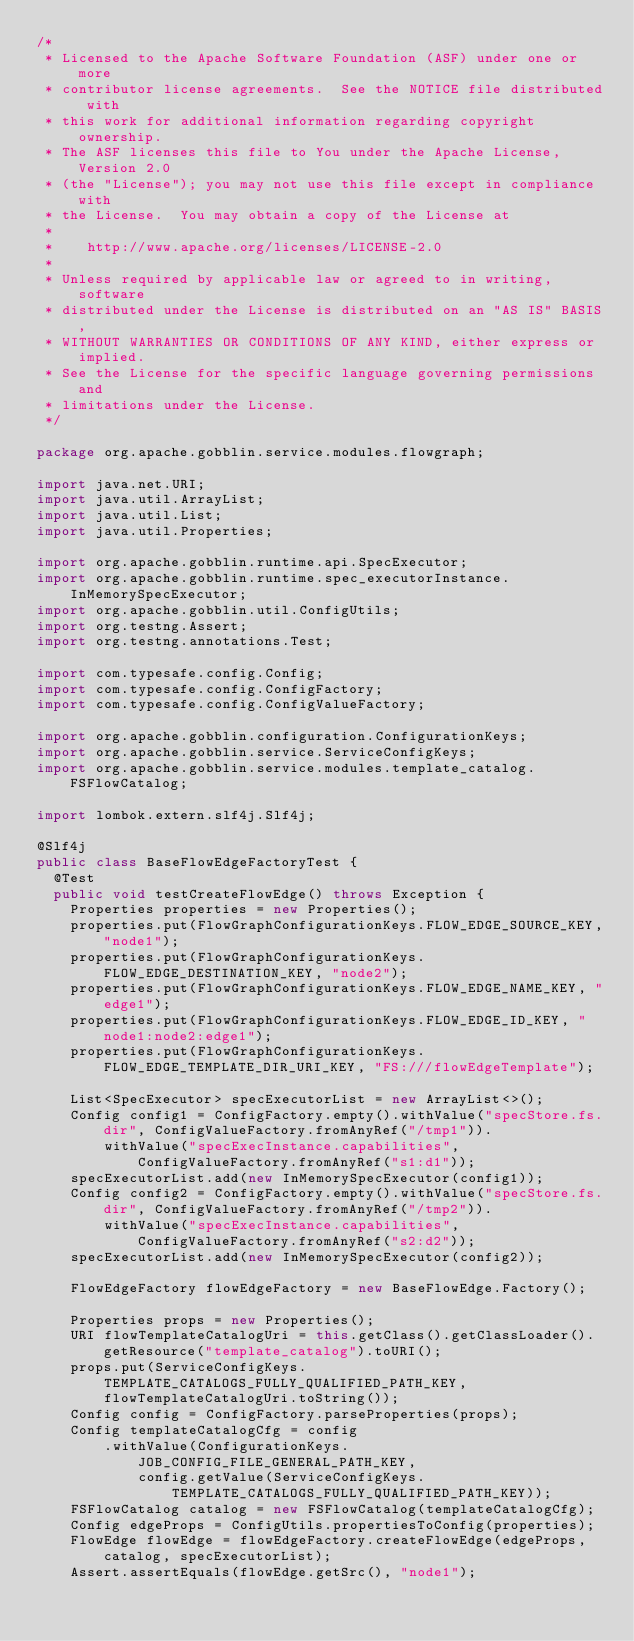Convert code to text. <code><loc_0><loc_0><loc_500><loc_500><_Java_>/*
 * Licensed to the Apache Software Foundation (ASF) under one or more
 * contributor license agreements.  See the NOTICE file distributed with
 * this work for additional information regarding copyright ownership.
 * The ASF licenses this file to You under the Apache License, Version 2.0
 * (the "License"); you may not use this file except in compliance with
 * the License.  You may obtain a copy of the License at
 *
 *    http://www.apache.org/licenses/LICENSE-2.0
 *
 * Unless required by applicable law or agreed to in writing, software
 * distributed under the License is distributed on an "AS IS" BASIS,
 * WITHOUT WARRANTIES OR CONDITIONS OF ANY KIND, either express or implied.
 * See the License for the specific language governing permissions and
 * limitations under the License.
 */

package org.apache.gobblin.service.modules.flowgraph;

import java.net.URI;
import java.util.ArrayList;
import java.util.List;
import java.util.Properties;

import org.apache.gobblin.runtime.api.SpecExecutor;
import org.apache.gobblin.runtime.spec_executorInstance.InMemorySpecExecutor;
import org.apache.gobblin.util.ConfigUtils;
import org.testng.Assert;
import org.testng.annotations.Test;

import com.typesafe.config.Config;
import com.typesafe.config.ConfigFactory;
import com.typesafe.config.ConfigValueFactory;

import org.apache.gobblin.configuration.ConfigurationKeys;
import org.apache.gobblin.service.ServiceConfigKeys;
import org.apache.gobblin.service.modules.template_catalog.FSFlowCatalog;

import lombok.extern.slf4j.Slf4j;

@Slf4j
public class BaseFlowEdgeFactoryTest {
  @Test
  public void testCreateFlowEdge() throws Exception {
    Properties properties = new Properties();
    properties.put(FlowGraphConfigurationKeys.FLOW_EDGE_SOURCE_KEY,"node1");
    properties.put(FlowGraphConfigurationKeys.FLOW_EDGE_DESTINATION_KEY, "node2");
    properties.put(FlowGraphConfigurationKeys.FLOW_EDGE_NAME_KEY, "edge1");
    properties.put(FlowGraphConfigurationKeys.FLOW_EDGE_ID_KEY, "node1:node2:edge1");
    properties.put(FlowGraphConfigurationKeys.FLOW_EDGE_TEMPLATE_DIR_URI_KEY, "FS:///flowEdgeTemplate");

    List<SpecExecutor> specExecutorList = new ArrayList<>();
    Config config1 = ConfigFactory.empty().withValue("specStore.fs.dir", ConfigValueFactory.fromAnyRef("/tmp1")).
        withValue("specExecInstance.capabilities", ConfigValueFactory.fromAnyRef("s1:d1"));
    specExecutorList.add(new InMemorySpecExecutor(config1));
    Config config2 = ConfigFactory.empty().withValue("specStore.fs.dir", ConfigValueFactory.fromAnyRef("/tmp2")).
        withValue("specExecInstance.capabilities", ConfigValueFactory.fromAnyRef("s2:d2"));
    specExecutorList.add(new InMemorySpecExecutor(config2));

    FlowEdgeFactory flowEdgeFactory = new BaseFlowEdge.Factory();

    Properties props = new Properties();
    URI flowTemplateCatalogUri = this.getClass().getClassLoader().getResource("template_catalog").toURI();
    props.put(ServiceConfigKeys.TEMPLATE_CATALOGS_FULLY_QUALIFIED_PATH_KEY, flowTemplateCatalogUri.toString());
    Config config = ConfigFactory.parseProperties(props);
    Config templateCatalogCfg = config
        .withValue(ConfigurationKeys.JOB_CONFIG_FILE_GENERAL_PATH_KEY,
            config.getValue(ServiceConfigKeys.TEMPLATE_CATALOGS_FULLY_QUALIFIED_PATH_KEY));
    FSFlowCatalog catalog = new FSFlowCatalog(templateCatalogCfg);
    Config edgeProps = ConfigUtils.propertiesToConfig(properties);
    FlowEdge flowEdge = flowEdgeFactory.createFlowEdge(edgeProps, catalog, specExecutorList);
    Assert.assertEquals(flowEdge.getSrc(), "node1");</code> 